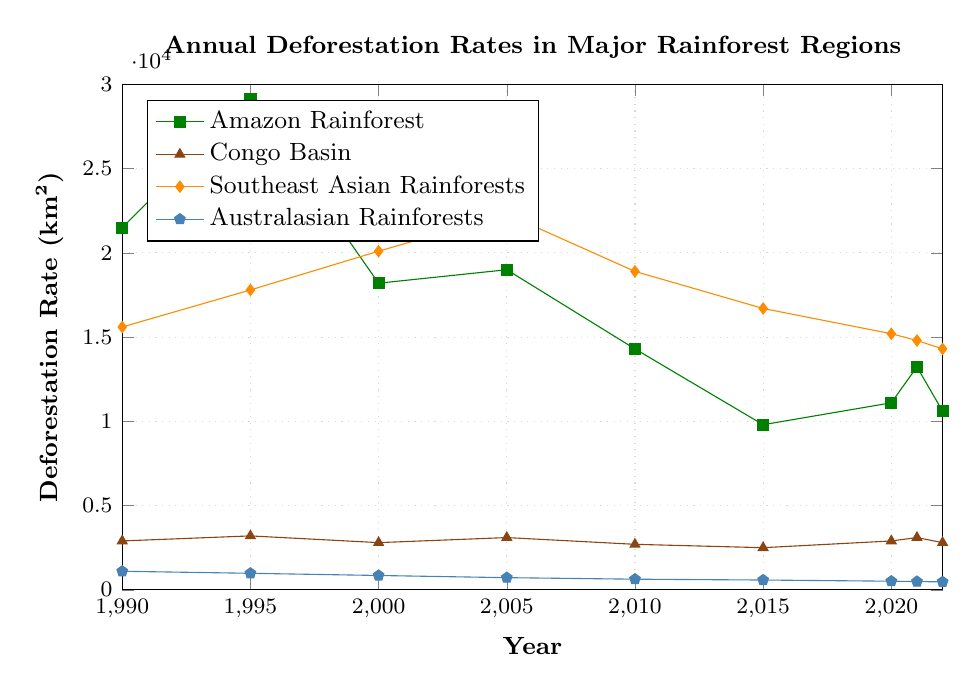What's the overall trend for deforestation in the Amazon Rainforest from 1990 to 2022? When examining the figure, the deforestation rate in the Amazon Rainforest started high in 1990, peaked in 1995, declined significantly by 2015, and then showed some fluctuations between 2015 and 2022.
Answer: Decreasing with fluctuations In which year did the Congo Basin experience the highest deforestation rate? By evaluating the deforestation rates presented in the figure, the highest rate for the Congo Basin appears to be in 2021.
Answer: 2021 Which rainforest had the lowest deforestation rate in 2022? Refer to the figure, compare each rainforest's deforestation rate in 2022. Australasian Rainforests had the lowest rate.
Answer: Australasian Rainforests What was the deforestation rate difference between the Amazon Rainforest and the Southeast Asian Rainforests in 2000? Locate the rates for both the Amazon Rainforest and Southeast Asian Rainforests in 2000 from the figure. The difference is (20100 - 18200).
Answer: 1900 Compare the overall trend in deforestation rates between the Southeast Asian Rainforests and Australasian Rainforests between 1990 and 2022. Observe the deforestation rates for both regions from 1990 to 2022 in the figure. The Southeast Asian Rainforests initially increased, peaked around 2005, and then decreased, whereas the Australasian Rainforests consistently decreased throughout the period.
Answer: Decreasing for both, sharper in Australasian What is the average deforestation rate for the Congo Basin from 1990 to 2022? Sum the deforestation rates of the Congo Basin from all the years provided and divide by the number of years: (2900+3200+2800+3100+2700+2500+2900+3100+2800) / 9.
Answer: 2899 Which year saw the most significant drop in deforestation in the Amazon Rainforest? Identify the year-to-year changes in deforestation rates and find the largest drop, which occurs between 1995 and 2000: (29100 to 18200).
Answer: 1995 to 2000 How do the deforestation rates in 1995 compare between the Amazon Rainforest and the Congo Basin? Compare the 1995 deforestation rates of these rainforests in the figure. The Amazon has a significantly higher rate than the Congo Basin.
Answer: Amazon higher than Congo Basin What are the median deforestation rates for the Amazon Rainforest over the displayed period? List the deforestation rates for the Amazon Rainforest: [21500, 29100, 18200, 19000, 14300, 9800, 11100, 13235, 10600]. Arrange these in ascending order: [9800, 10600, 11100, 13235, 14300, 18200, 19000, 21500, 29100], the median is the middle value: 14300.
Answer: 14300 